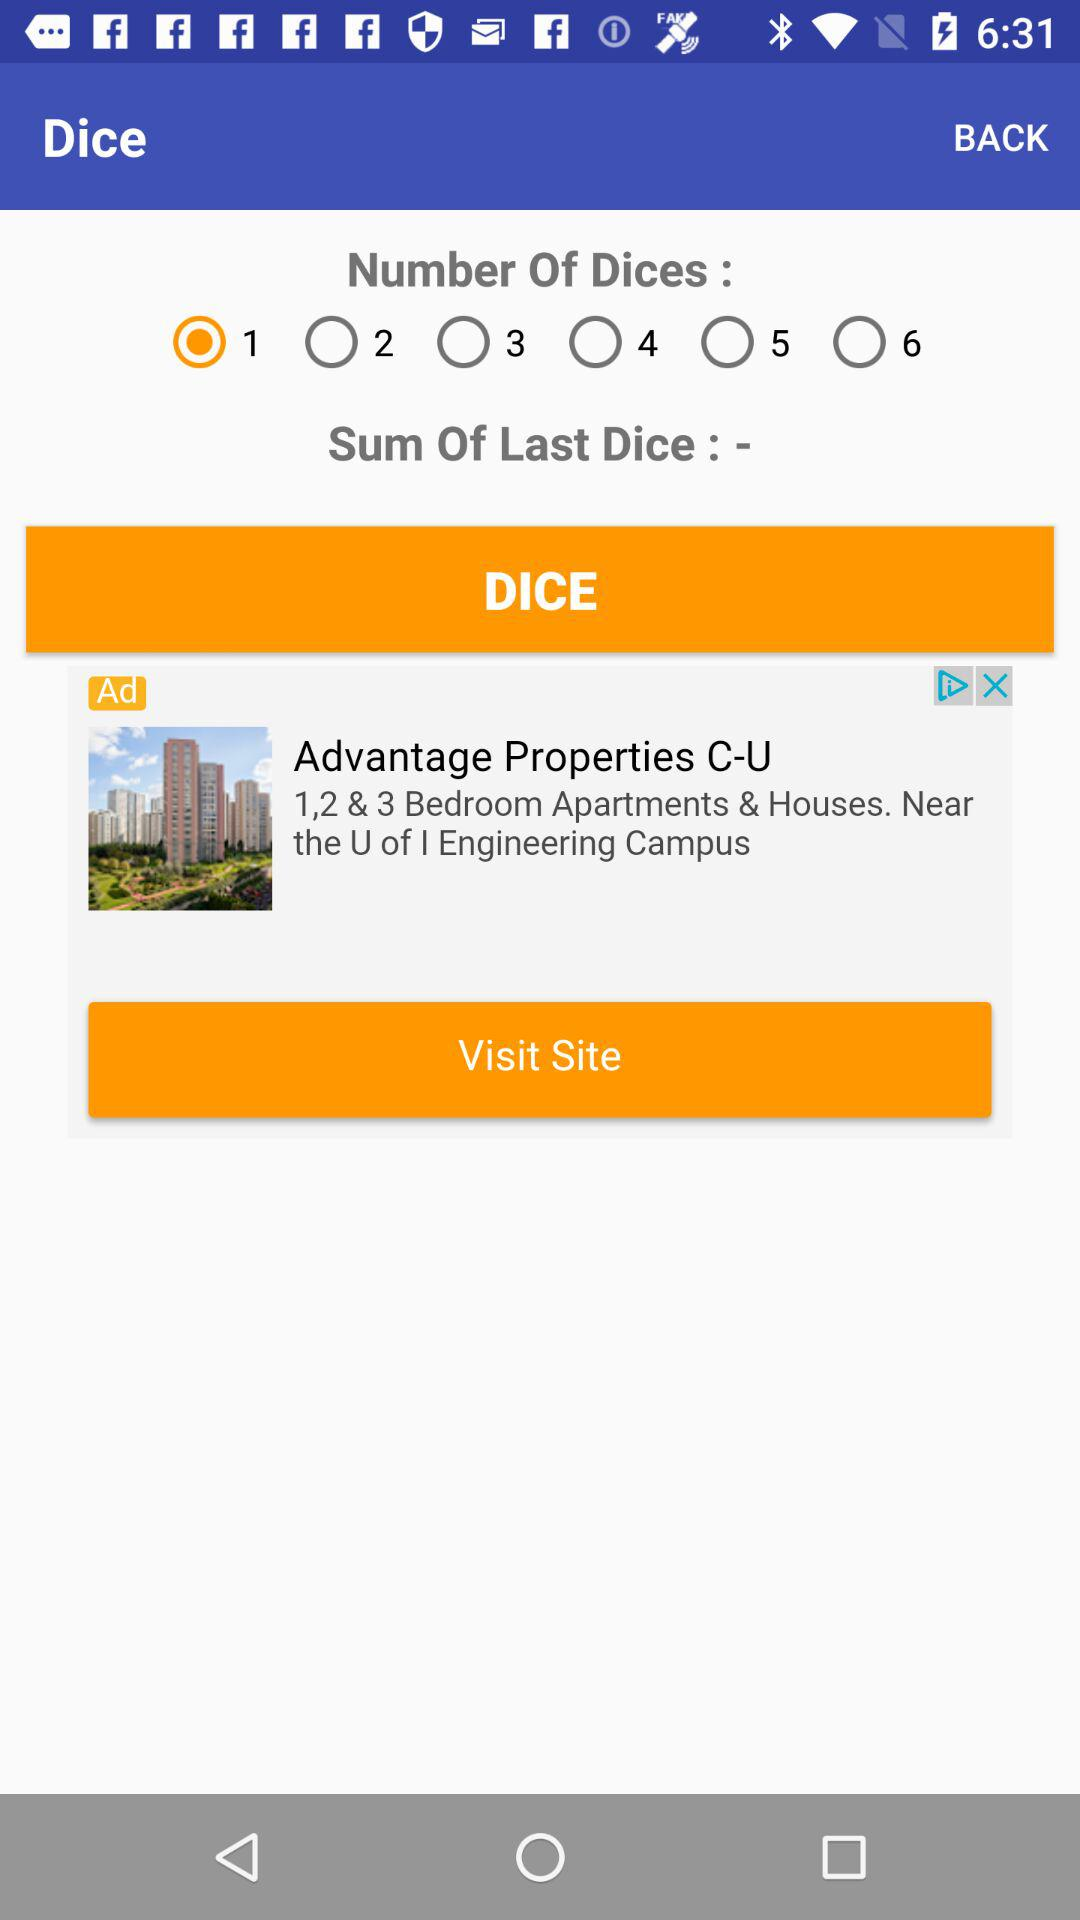Which option is selected? The selected option is "1". 